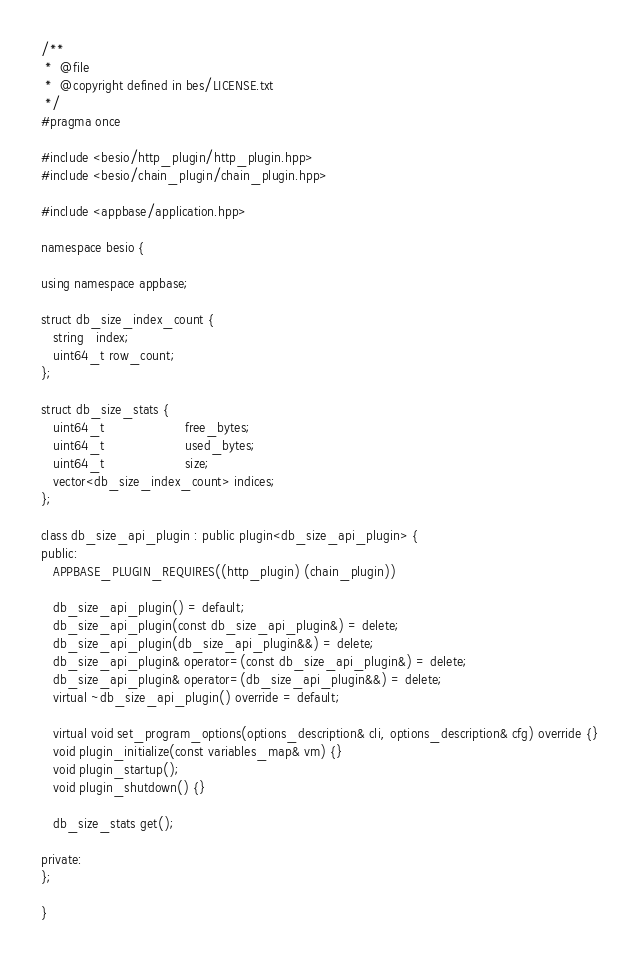<code> <loc_0><loc_0><loc_500><loc_500><_C++_>/**
 *  @file
 *  @copyright defined in bes/LICENSE.txt
 */
#pragma once

#include <besio/http_plugin/http_plugin.hpp>
#include <besio/chain_plugin/chain_plugin.hpp>

#include <appbase/application.hpp>

namespace besio {

using namespace appbase;

struct db_size_index_count {
   string   index;
   uint64_t row_count;
};

struct db_size_stats {
   uint64_t                    free_bytes;
   uint64_t                    used_bytes;
   uint64_t                    size;
   vector<db_size_index_count> indices;
};

class db_size_api_plugin : public plugin<db_size_api_plugin> {
public:
   APPBASE_PLUGIN_REQUIRES((http_plugin) (chain_plugin))

   db_size_api_plugin() = default;
   db_size_api_plugin(const db_size_api_plugin&) = delete;
   db_size_api_plugin(db_size_api_plugin&&) = delete;
   db_size_api_plugin& operator=(const db_size_api_plugin&) = delete;
   db_size_api_plugin& operator=(db_size_api_plugin&&) = delete;
   virtual ~db_size_api_plugin() override = default;

   virtual void set_program_options(options_description& cli, options_description& cfg) override {}
   void plugin_initialize(const variables_map& vm) {}
   void plugin_startup();
   void plugin_shutdown() {}

   db_size_stats get();

private:
};

}
</code> 